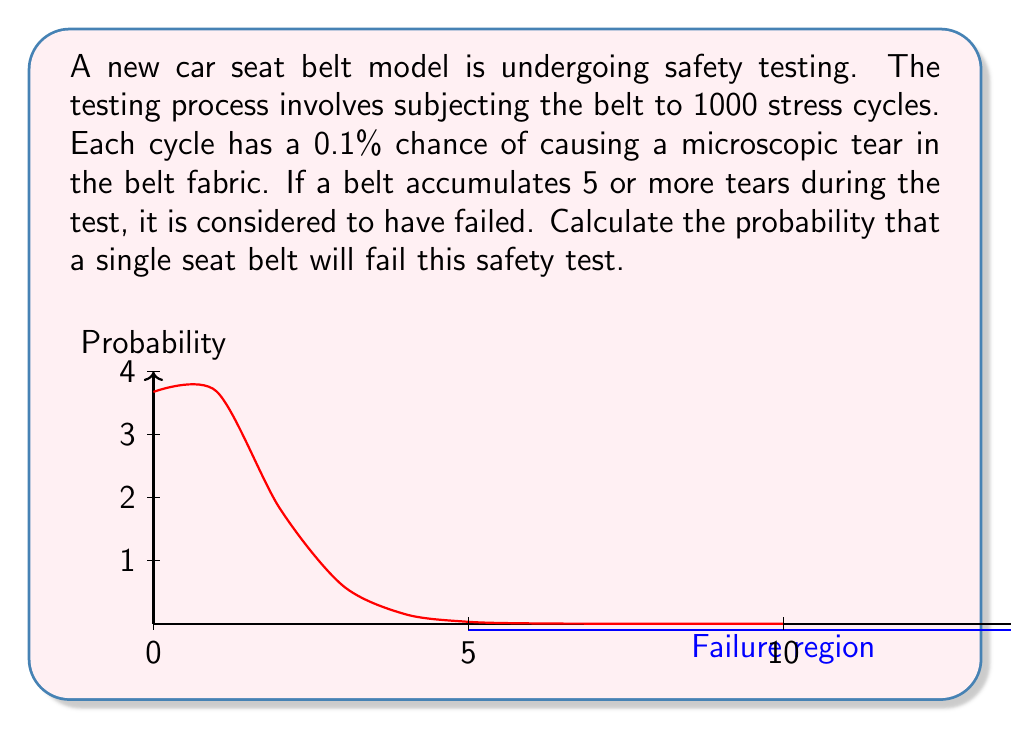What is the answer to this math problem? To solve this problem, we need to use the binomial distribution and calculate the cumulative probability of 5 or more tears occurring.

1) First, let's define our parameters:
   $n = 1000$ (number of trials/cycles)
   $p = 0.001$ (probability of a tear in each cycle)
   $X$ = number of tears (our random variable)

2) We need to find $P(X \geq 5)$, which is equivalent to $1 - P(X < 5)$ or $1 - P(X \leq 4)$

3) The probability mass function for the binomial distribution is:

   $$P(X = k) = \binom{n}{k} p^k (1-p)^{n-k}$$

4) We can calculate $P(X \leq 4)$ by summing $P(X = k)$ for $k = 0$ to $4$:

   $$P(X \leq 4) = \sum_{k=0}^4 \binom{1000}{k} (0.001)^k (0.999)^{1000-k}$$

5) Calculating this sum:
   
   $P(X = 0) = 0.3678794$
   $P(X = 1) = 0.3682132$
   $P(X = 2) = 0.1841613$
   $P(X = 3) = 0.0613479$
   $P(X = 4) = 0.0153433$

   $P(X \leq 4) = 0.9969451$

6) Therefore, the probability of failure (5 or more tears) is:

   $P(X \geq 5) = 1 - P(X \leq 4) = 1 - 0.9969451 = 0.0030549$
Answer: $0.0030549$ or approximately $0.31\%$ 